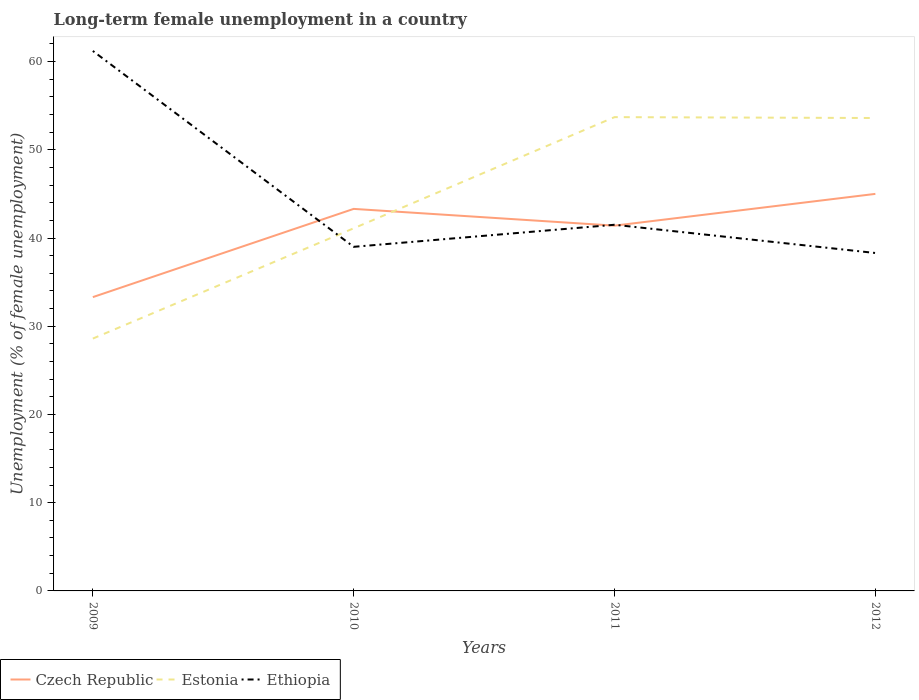How many different coloured lines are there?
Your answer should be compact. 3. Does the line corresponding to Czech Republic intersect with the line corresponding to Ethiopia?
Offer a very short reply. Yes. Is the number of lines equal to the number of legend labels?
Your answer should be compact. Yes. Across all years, what is the maximum percentage of long-term unemployed female population in Czech Republic?
Your answer should be compact. 33.3. In which year was the percentage of long-term unemployed female population in Estonia maximum?
Provide a succinct answer. 2009. What is the total percentage of long-term unemployed female population in Estonia in the graph?
Your answer should be very brief. -25. What is the difference between the highest and the second highest percentage of long-term unemployed female population in Ethiopia?
Keep it short and to the point. 22.9. Is the percentage of long-term unemployed female population in Estonia strictly greater than the percentage of long-term unemployed female population in Czech Republic over the years?
Your answer should be compact. No. How many years are there in the graph?
Offer a terse response. 4. What is the difference between two consecutive major ticks on the Y-axis?
Give a very brief answer. 10. Are the values on the major ticks of Y-axis written in scientific E-notation?
Offer a very short reply. No. Where does the legend appear in the graph?
Ensure brevity in your answer.  Bottom left. How many legend labels are there?
Provide a succinct answer. 3. How are the legend labels stacked?
Provide a succinct answer. Horizontal. What is the title of the graph?
Keep it short and to the point. Long-term female unemployment in a country. What is the label or title of the X-axis?
Ensure brevity in your answer.  Years. What is the label or title of the Y-axis?
Provide a succinct answer. Unemployment (% of female unemployment). What is the Unemployment (% of female unemployment) of Czech Republic in 2009?
Give a very brief answer. 33.3. What is the Unemployment (% of female unemployment) in Estonia in 2009?
Offer a very short reply. 28.6. What is the Unemployment (% of female unemployment) of Ethiopia in 2009?
Keep it short and to the point. 61.2. What is the Unemployment (% of female unemployment) in Czech Republic in 2010?
Keep it short and to the point. 43.3. What is the Unemployment (% of female unemployment) of Estonia in 2010?
Ensure brevity in your answer.  41.1. What is the Unemployment (% of female unemployment) of Czech Republic in 2011?
Provide a succinct answer. 41.4. What is the Unemployment (% of female unemployment) in Estonia in 2011?
Offer a very short reply. 53.7. What is the Unemployment (% of female unemployment) of Ethiopia in 2011?
Provide a short and direct response. 41.5. What is the Unemployment (% of female unemployment) of Estonia in 2012?
Your answer should be very brief. 53.6. What is the Unemployment (% of female unemployment) of Ethiopia in 2012?
Keep it short and to the point. 38.3. Across all years, what is the maximum Unemployment (% of female unemployment) in Estonia?
Offer a very short reply. 53.7. Across all years, what is the maximum Unemployment (% of female unemployment) of Ethiopia?
Offer a very short reply. 61.2. Across all years, what is the minimum Unemployment (% of female unemployment) in Czech Republic?
Offer a terse response. 33.3. Across all years, what is the minimum Unemployment (% of female unemployment) in Estonia?
Give a very brief answer. 28.6. Across all years, what is the minimum Unemployment (% of female unemployment) of Ethiopia?
Make the answer very short. 38.3. What is the total Unemployment (% of female unemployment) in Czech Republic in the graph?
Offer a terse response. 163. What is the total Unemployment (% of female unemployment) of Estonia in the graph?
Give a very brief answer. 177. What is the total Unemployment (% of female unemployment) of Ethiopia in the graph?
Keep it short and to the point. 180. What is the difference between the Unemployment (% of female unemployment) of Estonia in 2009 and that in 2011?
Your response must be concise. -25.1. What is the difference between the Unemployment (% of female unemployment) in Ethiopia in 2009 and that in 2011?
Your response must be concise. 19.7. What is the difference between the Unemployment (% of female unemployment) of Czech Republic in 2009 and that in 2012?
Provide a short and direct response. -11.7. What is the difference between the Unemployment (% of female unemployment) of Estonia in 2009 and that in 2012?
Ensure brevity in your answer.  -25. What is the difference between the Unemployment (% of female unemployment) of Ethiopia in 2009 and that in 2012?
Offer a terse response. 22.9. What is the difference between the Unemployment (% of female unemployment) of Ethiopia in 2010 and that in 2011?
Offer a very short reply. -2.5. What is the difference between the Unemployment (% of female unemployment) of Czech Republic in 2010 and that in 2012?
Your response must be concise. -1.7. What is the difference between the Unemployment (% of female unemployment) of Estonia in 2011 and that in 2012?
Provide a short and direct response. 0.1. What is the difference between the Unemployment (% of female unemployment) in Ethiopia in 2011 and that in 2012?
Offer a very short reply. 3.2. What is the difference between the Unemployment (% of female unemployment) in Czech Republic in 2009 and the Unemployment (% of female unemployment) in Ethiopia in 2010?
Your answer should be very brief. -5.7. What is the difference between the Unemployment (% of female unemployment) in Estonia in 2009 and the Unemployment (% of female unemployment) in Ethiopia in 2010?
Ensure brevity in your answer.  -10.4. What is the difference between the Unemployment (% of female unemployment) in Czech Republic in 2009 and the Unemployment (% of female unemployment) in Estonia in 2011?
Offer a terse response. -20.4. What is the difference between the Unemployment (% of female unemployment) in Czech Republic in 2009 and the Unemployment (% of female unemployment) in Ethiopia in 2011?
Offer a terse response. -8.2. What is the difference between the Unemployment (% of female unemployment) of Estonia in 2009 and the Unemployment (% of female unemployment) of Ethiopia in 2011?
Your response must be concise. -12.9. What is the difference between the Unemployment (% of female unemployment) in Czech Republic in 2009 and the Unemployment (% of female unemployment) in Estonia in 2012?
Provide a short and direct response. -20.3. What is the difference between the Unemployment (% of female unemployment) in Estonia in 2009 and the Unemployment (% of female unemployment) in Ethiopia in 2012?
Your answer should be very brief. -9.7. What is the difference between the Unemployment (% of female unemployment) in Czech Republic in 2010 and the Unemployment (% of female unemployment) in Estonia in 2011?
Provide a succinct answer. -10.4. What is the difference between the Unemployment (% of female unemployment) of Czech Republic in 2010 and the Unemployment (% of female unemployment) of Estonia in 2012?
Give a very brief answer. -10.3. What is the difference between the Unemployment (% of female unemployment) in Estonia in 2010 and the Unemployment (% of female unemployment) in Ethiopia in 2012?
Your answer should be compact. 2.8. What is the difference between the Unemployment (% of female unemployment) in Czech Republic in 2011 and the Unemployment (% of female unemployment) in Estonia in 2012?
Ensure brevity in your answer.  -12.2. What is the difference between the Unemployment (% of female unemployment) of Estonia in 2011 and the Unemployment (% of female unemployment) of Ethiopia in 2012?
Provide a succinct answer. 15.4. What is the average Unemployment (% of female unemployment) of Czech Republic per year?
Offer a very short reply. 40.75. What is the average Unemployment (% of female unemployment) of Estonia per year?
Ensure brevity in your answer.  44.25. What is the average Unemployment (% of female unemployment) of Ethiopia per year?
Provide a short and direct response. 45. In the year 2009, what is the difference between the Unemployment (% of female unemployment) of Czech Republic and Unemployment (% of female unemployment) of Estonia?
Keep it short and to the point. 4.7. In the year 2009, what is the difference between the Unemployment (% of female unemployment) of Czech Republic and Unemployment (% of female unemployment) of Ethiopia?
Offer a very short reply. -27.9. In the year 2009, what is the difference between the Unemployment (% of female unemployment) in Estonia and Unemployment (% of female unemployment) in Ethiopia?
Provide a short and direct response. -32.6. In the year 2010, what is the difference between the Unemployment (% of female unemployment) in Czech Republic and Unemployment (% of female unemployment) in Estonia?
Your response must be concise. 2.2. In the year 2010, what is the difference between the Unemployment (% of female unemployment) of Estonia and Unemployment (% of female unemployment) of Ethiopia?
Your answer should be very brief. 2.1. In the year 2011, what is the difference between the Unemployment (% of female unemployment) of Czech Republic and Unemployment (% of female unemployment) of Estonia?
Offer a terse response. -12.3. In the year 2011, what is the difference between the Unemployment (% of female unemployment) in Czech Republic and Unemployment (% of female unemployment) in Ethiopia?
Provide a short and direct response. -0.1. In the year 2011, what is the difference between the Unemployment (% of female unemployment) of Estonia and Unemployment (% of female unemployment) of Ethiopia?
Provide a succinct answer. 12.2. In the year 2012, what is the difference between the Unemployment (% of female unemployment) of Czech Republic and Unemployment (% of female unemployment) of Estonia?
Ensure brevity in your answer.  -8.6. In the year 2012, what is the difference between the Unemployment (% of female unemployment) in Czech Republic and Unemployment (% of female unemployment) in Ethiopia?
Offer a terse response. 6.7. What is the ratio of the Unemployment (% of female unemployment) in Czech Republic in 2009 to that in 2010?
Keep it short and to the point. 0.77. What is the ratio of the Unemployment (% of female unemployment) in Estonia in 2009 to that in 2010?
Offer a terse response. 0.7. What is the ratio of the Unemployment (% of female unemployment) in Ethiopia in 2009 to that in 2010?
Ensure brevity in your answer.  1.57. What is the ratio of the Unemployment (% of female unemployment) of Czech Republic in 2009 to that in 2011?
Provide a succinct answer. 0.8. What is the ratio of the Unemployment (% of female unemployment) in Estonia in 2009 to that in 2011?
Keep it short and to the point. 0.53. What is the ratio of the Unemployment (% of female unemployment) in Ethiopia in 2009 to that in 2011?
Give a very brief answer. 1.47. What is the ratio of the Unemployment (% of female unemployment) in Czech Republic in 2009 to that in 2012?
Your response must be concise. 0.74. What is the ratio of the Unemployment (% of female unemployment) of Estonia in 2009 to that in 2012?
Your answer should be compact. 0.53. What is the ratio of the Unemployment (% of female unemployment) of Ethiopia in 2009 to that in 2012?
Your answer should be compact. 1.6. What is the ratio of the Unemployment (% of female unemployment) of Czech Republic in 2010 to that in 2011?
Ensure brevity in your answer.  1.05. What is the ratio of the Unemployment (% of female unemployment) of Estonia in 2010 to that in 2011?
Offer a terse response. 0.77. What is the ratio of the Unemployment (% of female unemployment) in Ethiopia in 2010 to that in 2011?
Give a very brief answer. 0.94. What is the ratio of the Unemployment (% of female unemployment) of Czech Republic in 2010 to that in 2012?
Provide a short and direct response. 0.96. What is the ratio of the Unemployment (% of female unemployment) in Estonia in 2010 to that in 2012?
Offer a very short reply. 0.77. What is the ratio of the Unemployment (% of female unemployment) of Ethiopia in 2010 to that in 2012?
Give a very brief answer. 1.02. What is the ratio of the Unemployment (% of female unemployment) in Ethiopia in 2011 to that in 2012?
Your answer should be compact. 1.08. What is the difference between the highest and the second highest Unemployment (% of female unemployment) in Czech Republic?
Provide a succinct answer. 1.7. What is the difference between the highest and the lowest Unemployment (% of female unemployment) of Czech Republic?
Your response must be concise. 11.7. What is the difference between the highest and the lowest Unemployment (% of female unemployment) in Estonia?
Your answer should be compact. 25.1. What is the difference between the highest and the lowest Unemployment (% of female unemployment) of Ethiopia?
Your response must be concise. 22.9. 